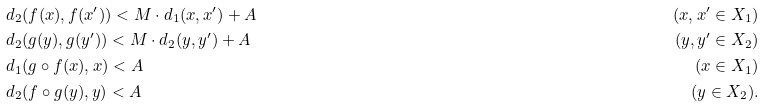Convert formula to latex. <formula><loc_0><loc_0><loc_500><loc_500>& d _ { 2 } ( f ( x ) , f ( x ^ { \prime } ) ) < M \cdot d _ { 1 } ( x , x ^ { \prime } ) + A \quad & ( x , x ^ { \prime } \in X _ { 1 } ) \\ & d _ { 2 } ( g ( y ) , g ( y ^ { \prime } ) ) < M \cdot d _ { 2 } ( y , y ^ { \prime } ) + A \quad & ( y , y ^ { \prime } \in X _ { 2 } ) \\ & d _ { 1 } ( g \circ f ( x ) , x ) < A \quad & ( x \in X _ { 1 } ) \\ & d _ { 2 } ( f \circ g ( y ) , y ) < A \quad & ( y \in X _ { 2 } ) .</formula> 